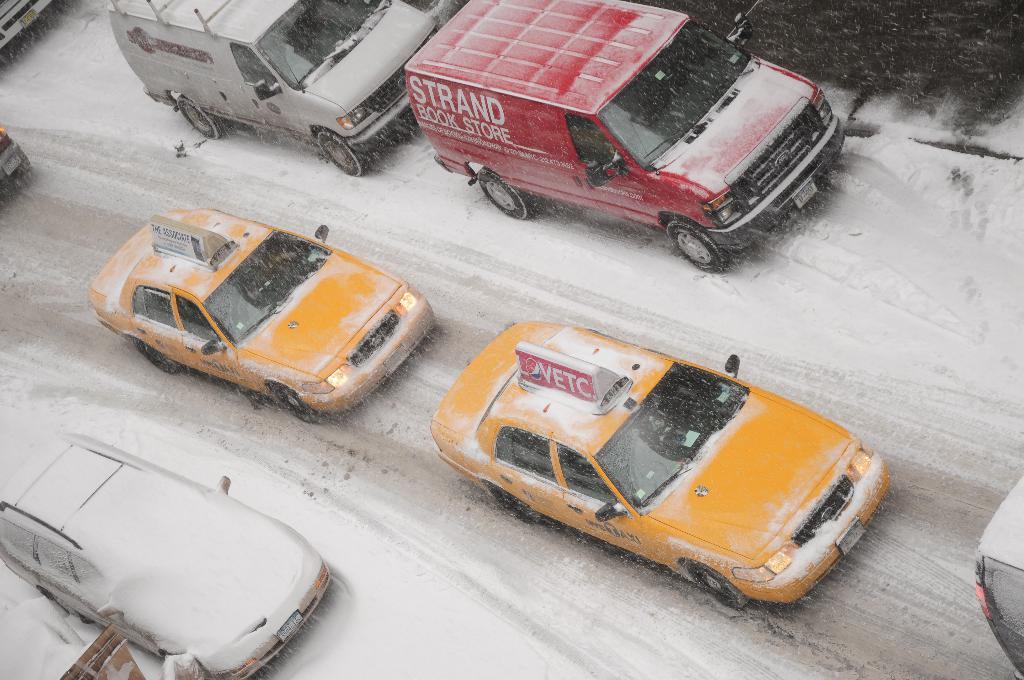What is on top of the first yellow car?
Provide a succinct answer. Vetc. What is on the side of the red van?
Provide a short and direct response. Strand book store. 